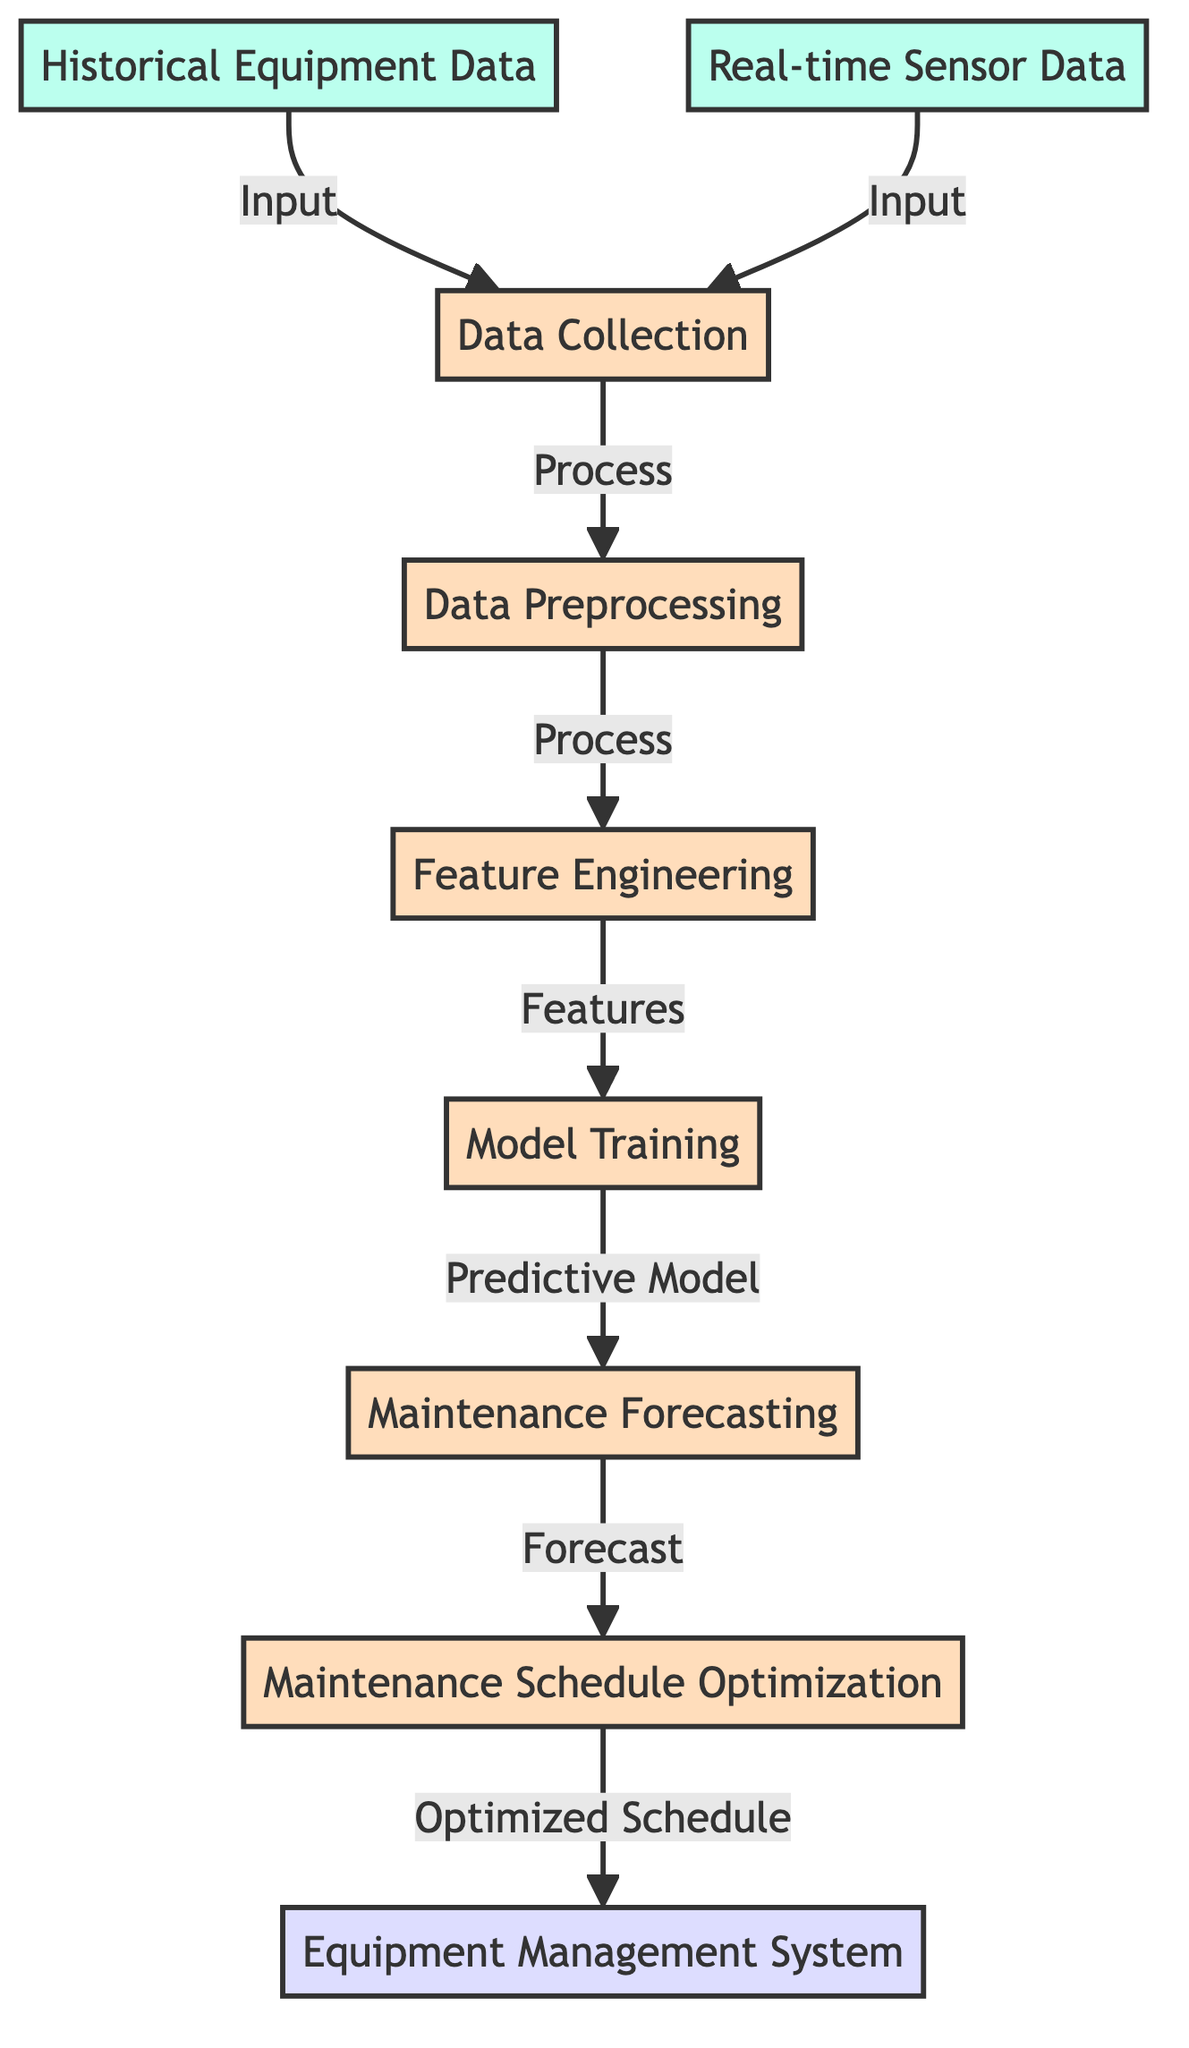What are the two main inputs to the data collection process? The diagram shows two nodes leading into the data collection process: "Historical Equipment Data" and "Real-time Sensor Data."
Answer: Historical Equipment Data, Real-time Sensor Data How many processes are involved in the predictive maintenance model? The diagram contains five process nodes: Data Collection, Data Preprocessing, Feature Engineering, Model Training, and Maintenance Forecasting.
Answer: Five What is the output of the maintenance schedule optimization process? The output of the schedule optimization process leads to the node labeled "Equipment Management System."
Answer: Equipment Management System Which process follows feature engineering? According to the flow of the diagram, after feature engineering, the next process is model training.
Answer: Model Training What is the relationship between model training and maintenance forecasting? The diagram indicates that model training produces a "Predictive Model," which is then used in the maintenance forecasting process.
Answer: Predictive Model What type of data is used for maintenance forecasting? The maintenance forecasting process takes input from the model training process. Thus, it uses the predictive model as its data.
Answer: Predictive Model Which process collects data for predictive maintenance? The initial process that collects data for predictive maintenance is the "Data Collection" process, which integrates historical and real-time data.
Answer: Data Collection How does the real-time sensor data connect within the diagram? The real-time sensor data directly connects to the data collection process as an input, integrating with historical equipment data.
Answer: Input to Data Collection What is the purpose of feature engineering in this diagram? Feature engineering transforms raw data into features that are necessary for effective model training. It acts as a critical step within the predictive maintenance framework.
Answer: Transform raw data into features 